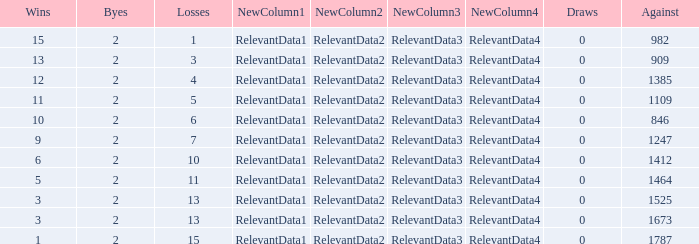What is the highest number listed under against when there were 15 losses and more than 1 win? None. Would you mind parsing the complete table? {'header': ['Wins', 'Byes', 'Losses', 'NewColumn1', 'NewColumn2', 'NewColumn3', 'NewColumn4', 'Draws', 'Against'], 'rows': [['15', '2', '1', 'RelevantData1', 'RelevantData2', 'RelevantData3', 'RelevantData4', '0', '982'], ['13', '2', '3', 'RelevantData1', 'RelevantData2', 'RelevantData3', 'RelevantData4', '0', '909'], ['12', '2', '4', 'RelevantData1', 'RelevantData2', 'RelevantData3', 'RelevantData4', '0', '1385'], ['11', '2', '5', 'RelevantData1', 'RelevantData2', 'RelevantData3', 'RelevantData4', '0', '1109'], ['10', '2', '6', 'RelevantData1', 'RelevantData2', 'RelevantData3', 'RelevantData4', '0', '846'], ['9', '2', '7', 'RelevantData1', 'RelevantData2', 'RelevantData3', 'RelevantData4', '0', '1247'], ['6', '2', '10', 'RelevantData1', 'RelevantData2', 'RelevantData3', 'RelevantData4', '0', '1412'], ['5', '2', '11', 'RelevantData1', 'RelevantData2', 'RelevantData3', 'RelevantData4', '0', '1464'], ['3', '2', '13', 'RelevantData1', 'RelevantData2', 'RelevantData3', 'RelevantData4', '0', '1525'], ['3', '2', '13', 'RelevantData1', 'RelevantData2', 'RelevantData3', 'RelevantData4', '0', '1673'], ['1', '2', '15', 'RelevantData1', 'RelevantData2', 'RelevantData3', 'RelevantData4', '0', '1787']]} 